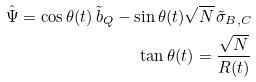Convert formula to latex. <formula><loc_0><loc_0><loc_500><loc_500>\hat { \Psi } = \cos \theta ( t ) \, \tilde { b } _ { Q } - \sin \theta ( t ) \sqrt { N } \, \tilde { \sigma } _ { B , C } \\ \tan \theta ( t ) = \frac { \sqrt { N } } { R ( t ) }</formula> 